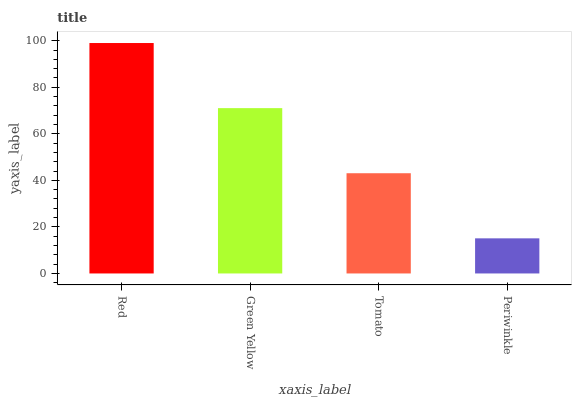Is Periwinkle the minimum?
Answer yes or no. Yes. Is Red the maximum?
Answer yes or no. Yes. Is Green Yellow the minimum?
Answer yes or no. No. Is Green Yellow the maximum?
Answer yes or no. No. Is Red greater than Green Yellow?
Answer yes or no. Yes. Is Green Yellow less than Red?
Answer yes or no. Yes. Is Green Yellow greater than Red?
Answer yes or no. No. Is Red less than Green Yellow?
Answer yes or no. No. Is Green Yellow the high median?
Answer yes or no. Yes. Is Tomato the low median?
Answer yes or no. Yes. Is Red the high median?
Answer yes or no. No. Is Red the low median?
Answer yes or no. No. 